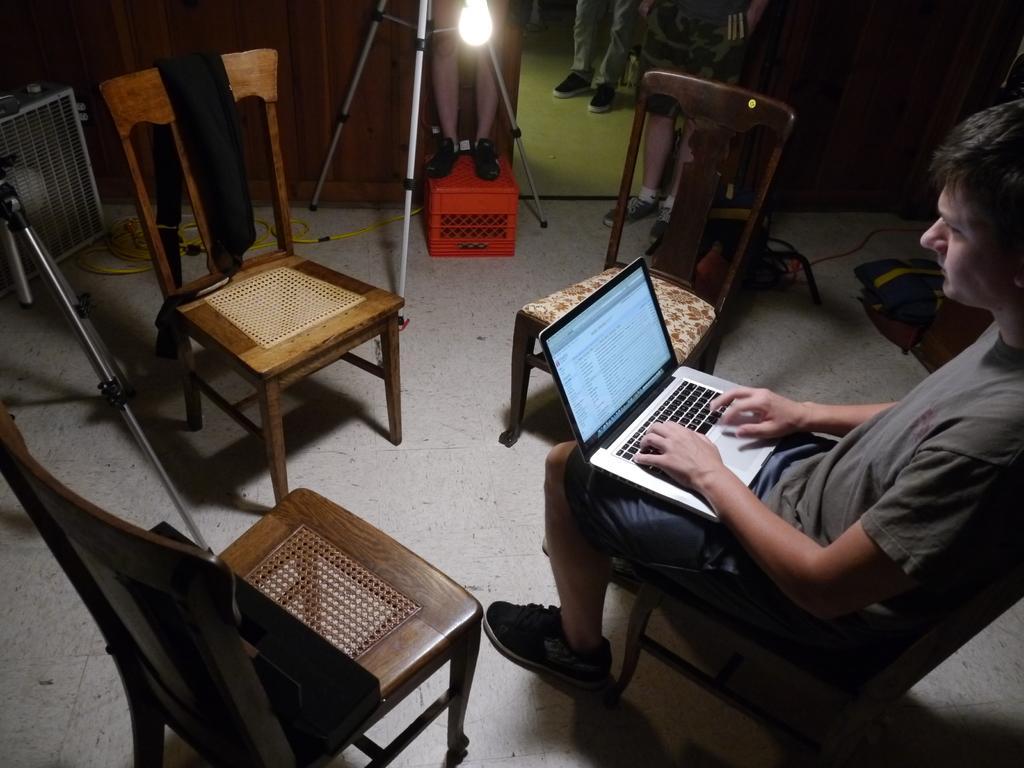Describe this image in one or two sentences. In this picture we can see man sitting on the chair. These are the chairs on the floor. Here we can see a light. And this is the floor. 